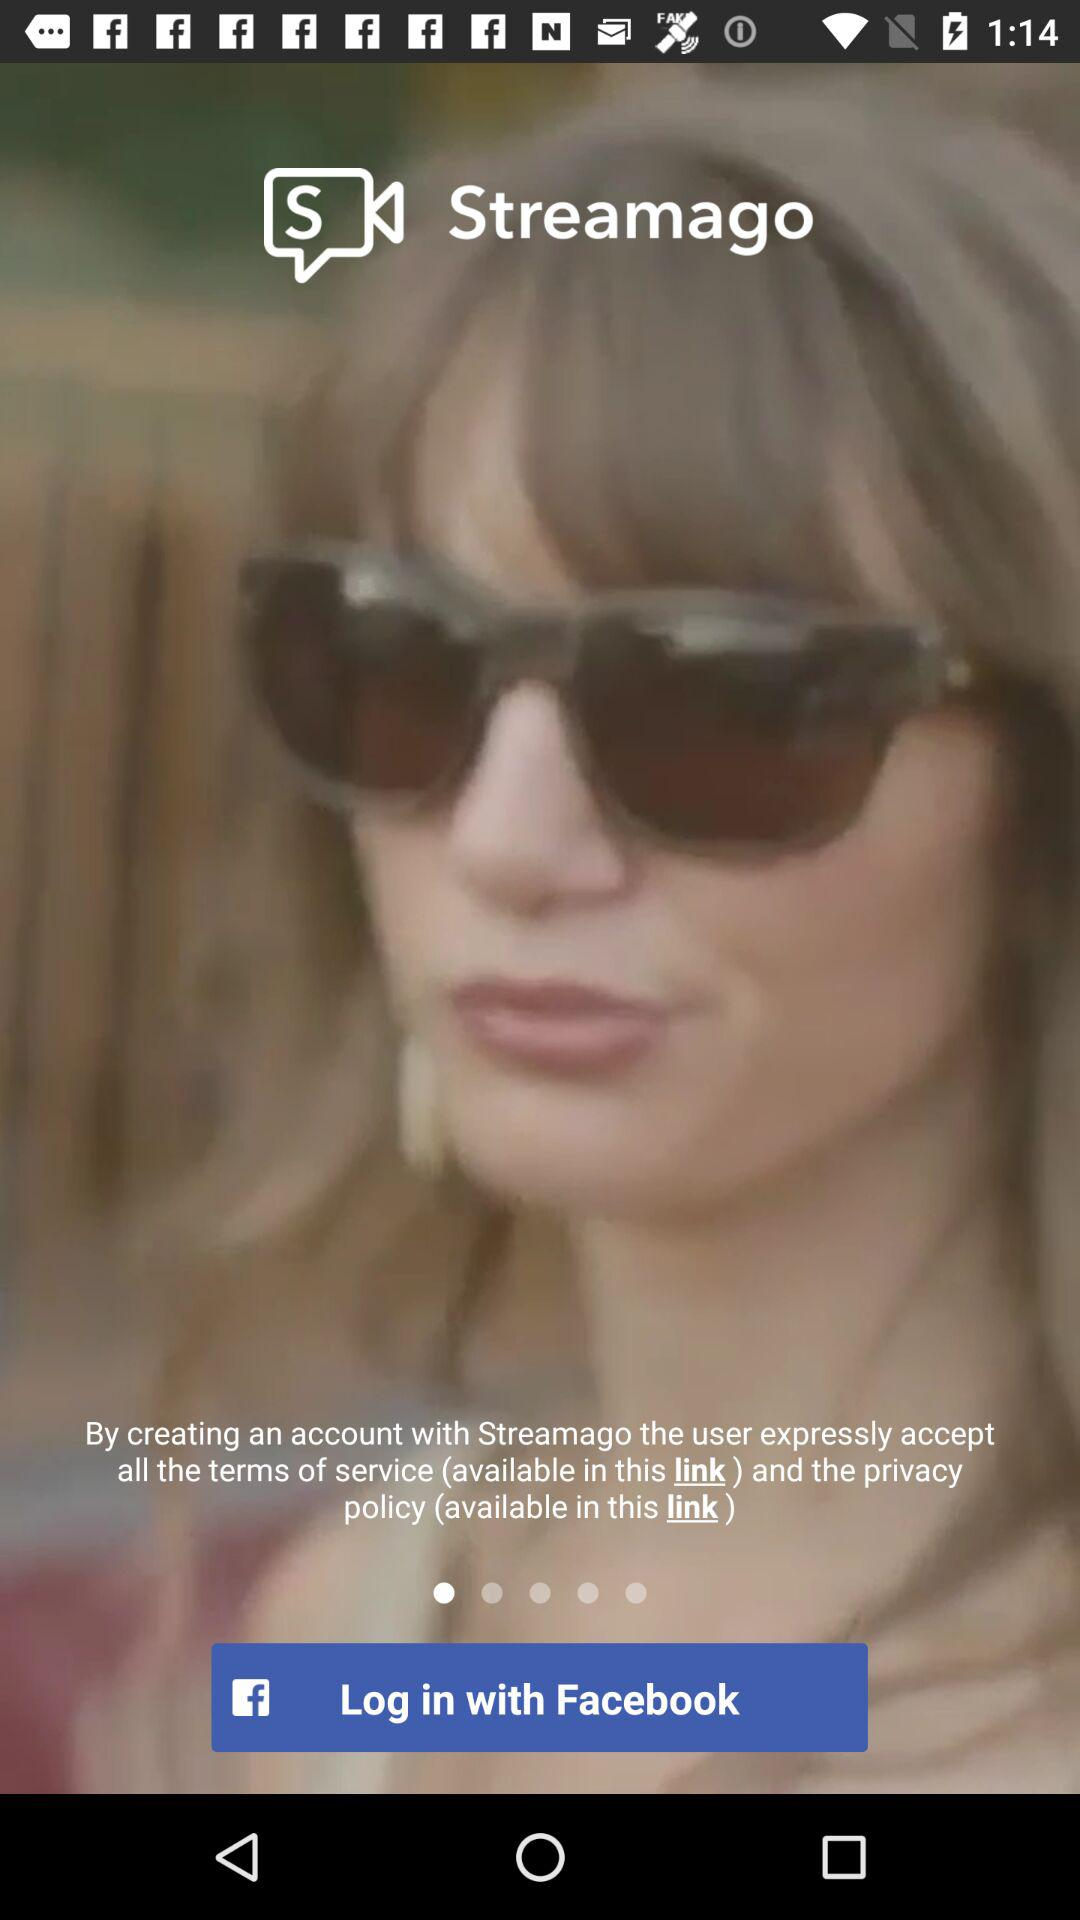What is the name of the application? The name of the application is "Streamago". 